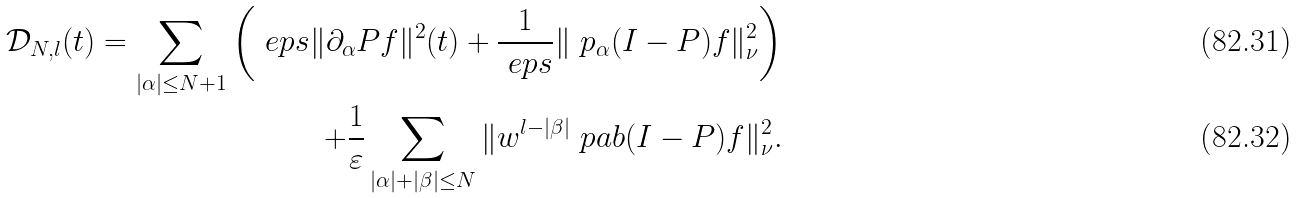<formula> <loc_0><loc_0><loc_500><loc_500>\mathcal { D } _ { N , l } ( t ) = \sum _ { | \alpha | \leq N + 1 } \left ( \ e p s \| \partial _ { \alpha } P f \| ^ { 2 } ( t ) + \frac { 1 } { \ e p s } \| \ p _ { \alpha } ( I - P ) f \| ^ { 2 } _ { \nu } \right ) \\ + \frac { 1 } { \varepsilon } \sum _ { | \alpha | + | \beta | \leq N } \| w ^ { l - | \beta | } \ p a b ( I - P ) f \| _ { \nu } ^ { 2 } .</formula> 